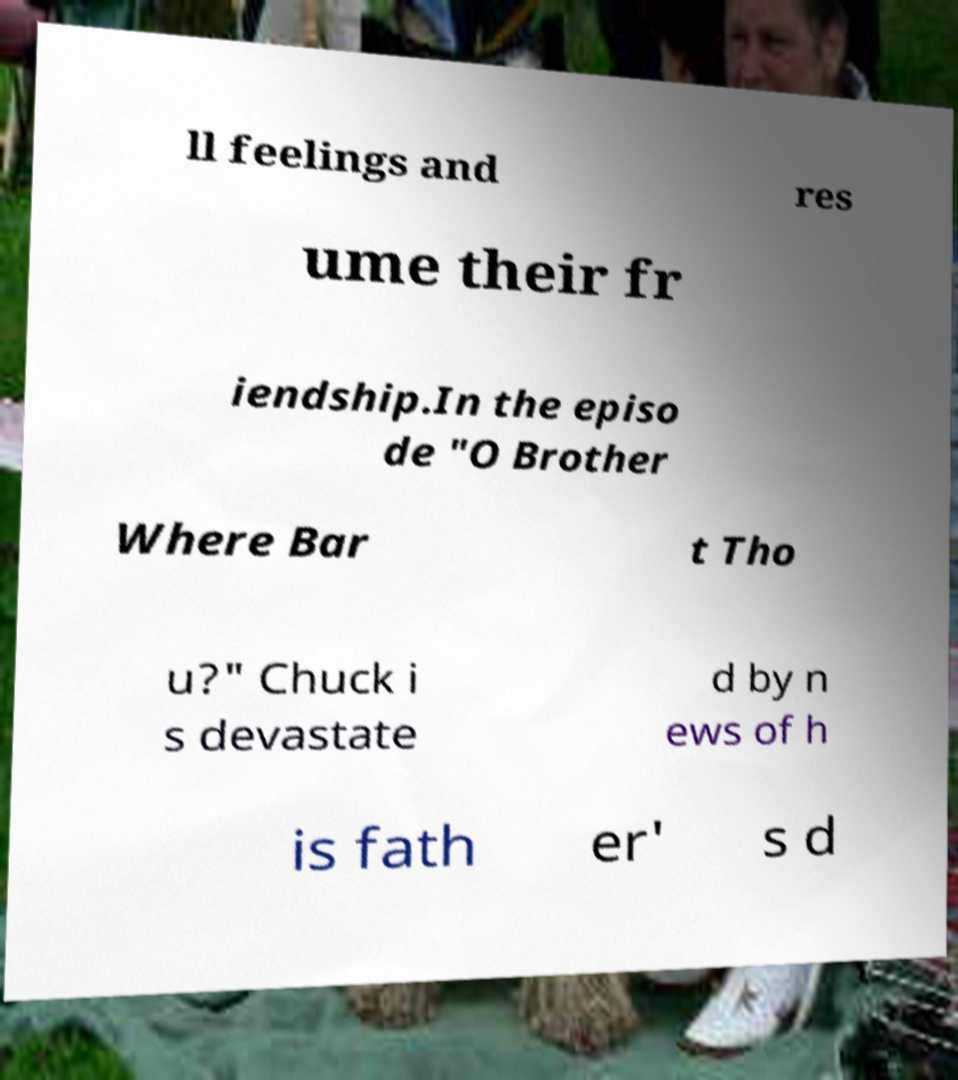Please identify and transcribe the text found in this image. ll feelings and res ume their fr iendship.In the episo de "O Brother Where Bar t Tho u?" Chuck i s devastate d by n ews of h is fath er' s d 